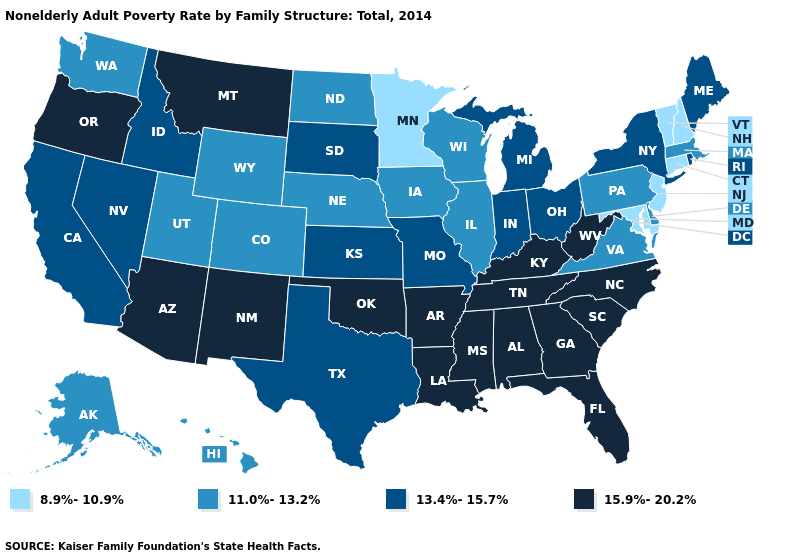Which states have the highest value in the USA?
Quick response, please. Alabama, Arizona, Arkansas, Florida, Georgia, Kentucky, Louisiana, Mississippi, Montana, New Mexico, North Carolina, Oklahoma, Oregon, South Carolina, Tennessee, West Virginia. Among the states that border Connecticut , which have the lowest value?
Give a very brief answer. Massachusetts. What is the value of North Dakota?
Give a very brief answer. 11.0%-13.2%. What is the value of Delaware?
Answer briefly. 11.0%-13.2%. What is the value of Idaho?
Concise answer only. 13.4%-15.7%. What is the value of Ohio?
Keep it brief. 13.4%-15.7%. Which states hav the highest value in the South?
Keep it brief. Alabama, Arkansas, Florida, Georgia, Kentucky, Louisiana, Mississippi, North Carolina, Oklahoma, South Carolina, Tennessee, West Virginia. Does Nebraska have the lowest value in the USA?
Short answer required. No. What is the value of Missouri?
Give a very brief answer. 13.4%-15.7%. What is the value of Rhode Island?
Give a very brief answer. 13.4%-15.7%. Name the states that have a value in the range 8.9%-10.9%?
Keep it brief. Connecticut, Maryland, Minnesota, New Hampshire, New Jersey, Vermont. Which states have the highest value in the USA?
Keep it brief. Alabama, Arizona, Arkansas, Florida, Georgia, Kentucky, Louisiana, Mississippi, Montana, New Mexico, North Carolina, Oklahoma, Oregon, South Carolina, Tennessee, West Virginia. What is the highest value in states that border Washington?
Give a very brief answer. 15.9%-20.2%. How many symbols are there in the legend?
Short answer required. 4. Does Maine have the highest value in the USA?
Write a very short answer. No. 